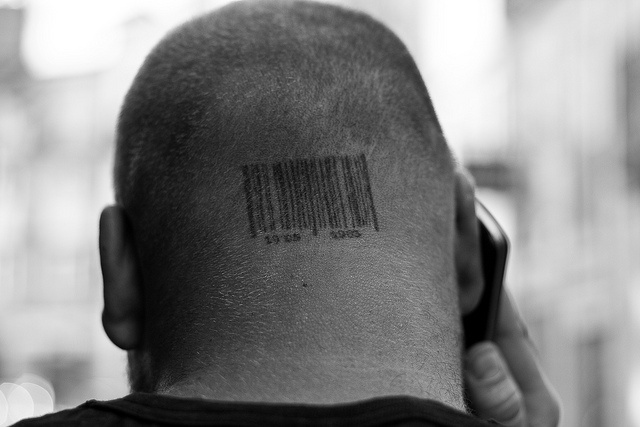Describe the objects in this image and their specific colors. I can see people in lightgray, gray, and black tones and cell phone in white, black, gray, darkgray, and lightgray tones in this image. 